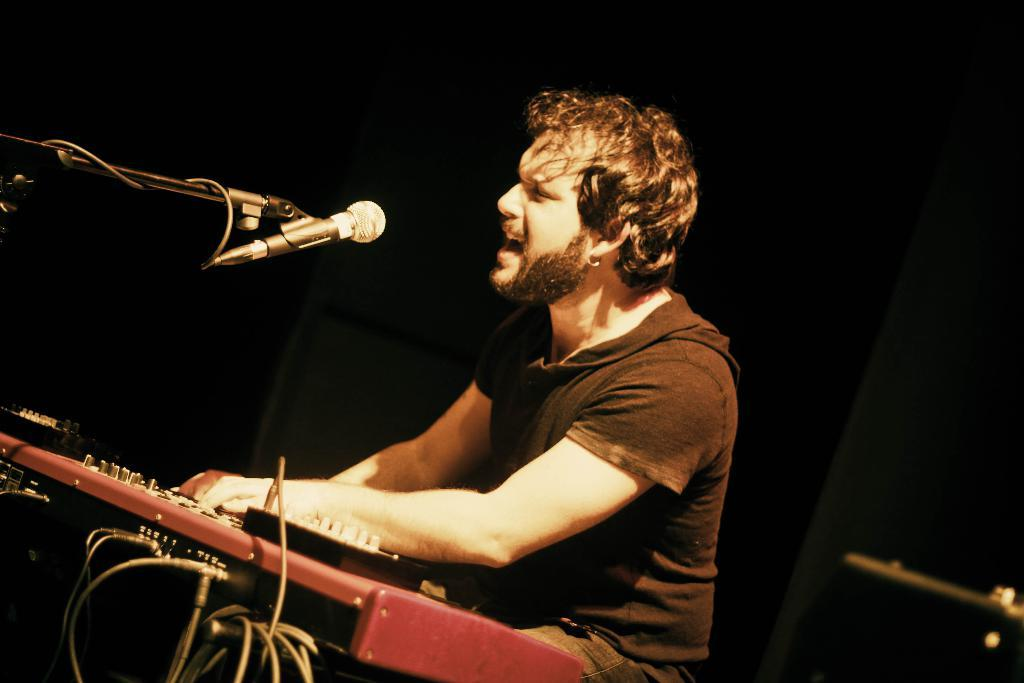What is the main subject of the image? There is a man sitting in the center of the image. What can be seen on the left side of the image? There is a music instrument and a microphone on the left side of the image. What is visible in the background of the image? There is a wall in the background of the image. What type of house is visible in the image? There is no house visible in the image. How does the man in the image demonstrate harmony with the music instrument? The image does not show the man playing the music instrument or interacting with it in any way, so it cannot be determined if he is demonstrating harmony with it. 